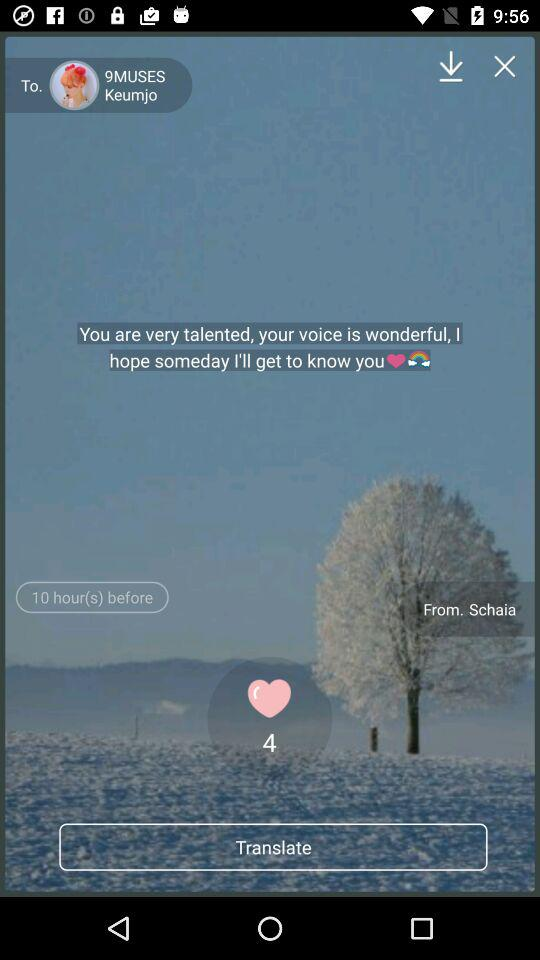How many hours ago was this message sent?
Answer the question using a single word or phrase. 10 